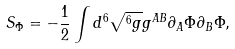Convert formula to latex. <formula><loc_0><loc_0><loc_500><loc_500>S _ { \Phi } = - \frac { 1 } { 2 } \int { d ^ { 6 } \sqrt { ^ { 6 } g } g ^ { A B } \partial _ { A } \Phi \partial _ { B } \Phi } ,</formula> 